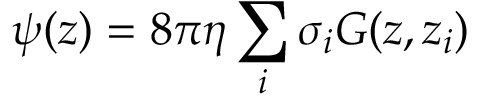<formula> <loc_0><loc_0><loc_500><loc_500>\psi ( z ) = 8 \pi \eta \sum _ { i } \sigma _ { i } G ( z , z _ { i } )</formula> 